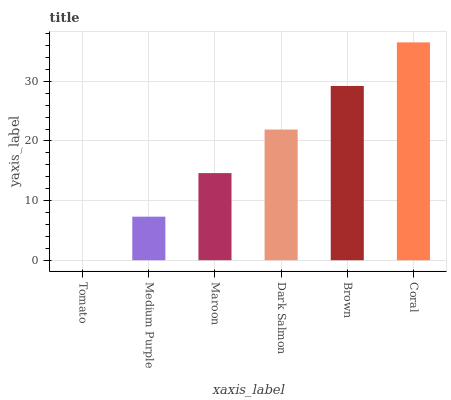Is Tomato the minimum?
Answer yes or no. Yes. Is Coral the maximum?
Answer yes or no. Yes. Is Medium Purple the minimum?
Answer yes or no. No. Is Medium Purple the maximum?
Answer yes or no. No. Is Medium Purple greater than Tomato?
Answer yes or no. Yes. Is Tomato less than Medium Purple?
Answer yes or no. Yes. Is Tomato greater than Medium Purple?
Answer yes or no. No. Is Medium Purple less than Tomato?
Answer yes or no. No. Is Dark Salmon the high median?
Answer yes or no. Yes. Is Maroon the low median?
Answer yes or no. Yes. Is Tomato the high median?
Answer yes or no. No. Is Brown the low median?
Answer yes or no. No. 